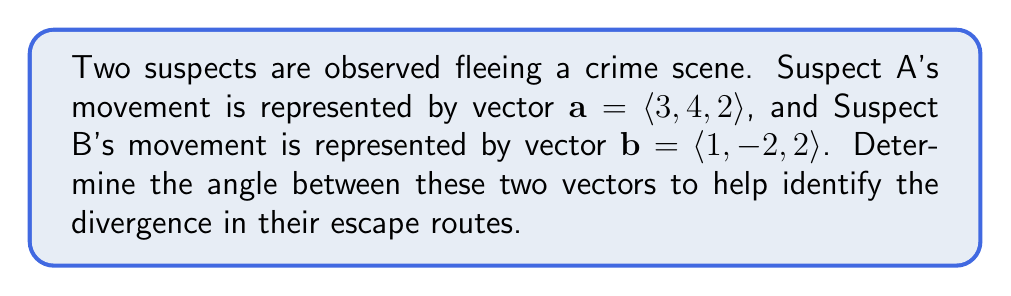Provide a solution to this math problem. To find the angle between two vectors, we can use the dot product formula:

$$\cos \theta = \frac{\mathbf{a} \cdot \mathbf{b}}{|\mathbf{a}||\mathbf{b}|}$$

Step 1: Calculate the dot product $\mathbf{a} \cdot \mathbf{b}$
$$\mathbf{a} \cdot \mathbf{b} = (3)(1) + (4)(-2) + (2)(2) = 3 - 8 + 4 = -1$$

Step 2: Calculate the magnitudes of vectors $\mathbf{a}$ and $\mathbf{b}$
$$|\mathbf{a}| = \sqrt{3^2 + 4^2 + 2^2} = \sqrt{9 + 16 + 4} = \sqrt{29}$$
$$|\mathbf{b}| = \sqrt{1^2 + (-2)^2 + 2^2} = \sqrt{1 + 4 + 4} = 3$$

Step 3: Substitute into the formula
$$\cos \theta = \frac{-1}{(\sqrt{29})(3)}$$

Step 4: Solve for $\theta$ using inverse cosine
$$\theta = \arccos\left(\frac{-1}{\sqrt{29} \cdot 3}\right)$$

Step 5: Calculate the result (rounded to two decimal places)
$$\theta \approx 1.76 \text{ radians}$$

Convert to degrees:
$$\theta \approx 1.76 \cdot \frac{180^{\circ}}{\pi} \approx 100.89^{\circ}$$
Answer: $100.89^{\circ}$ 